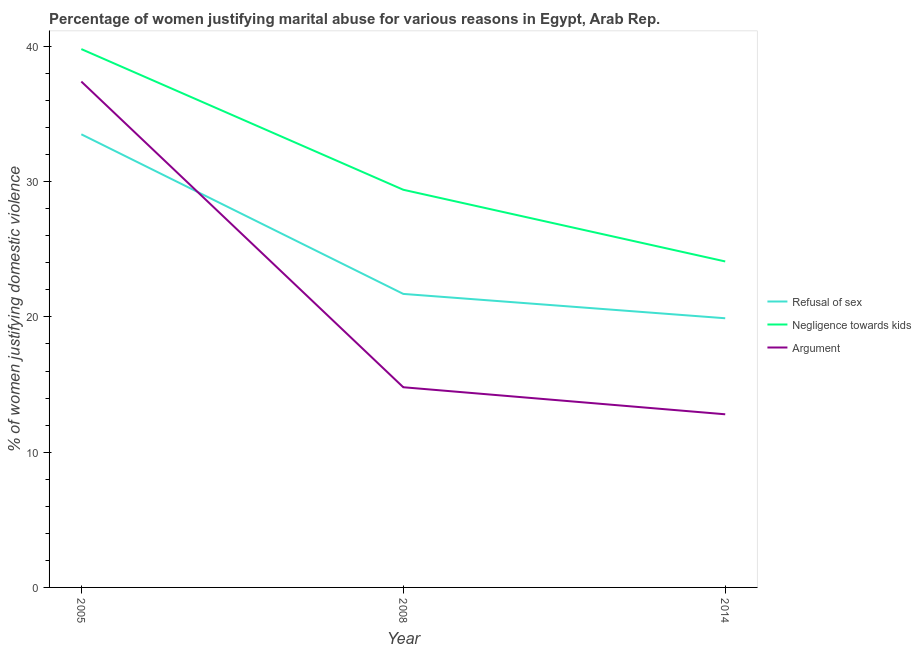Does the line corresponding to percentage of women justifying domestic violence due to refusal of sex intersect with the line corresponding to percentage of women justifying domestic violence due to negligence towards kids?
Keep it short and to the point. No. Across all years, what is the maximum percentage of women justifying domestic violence due to negligence towards kids?
Keep it short and to the point. 39.8. Across all years, what is the minimum percentage of women justifying domestic violence due to negligence towards kids?
Your response must be concise. 24.1. What is the total percentage of women justifying domestic violence due to negligence towards kids in the graph?
Your answer should be very brief. 93.3. What is the difference between the percentage of women justifying domestic violence due to negligence towards kids in 2008 and that in 2014?
Ensure brevity in your answer.  5.3. What is the difference between the percentage of women justifying domestic violence due to refusal of sex in 2008 and the percentage of women justifying domestic violence due to arguments in 2005?
Offer a terse response. -15.7. What is the average percentage of women justifying domestic violence due to refusal of sex per year?
Give a very brief answer. 25.03. In the year 2008, what is the difference between the percentage of women justifying domestic violence due to negligence towards kids and percentage of women justifying domestic violence due to arguments?
Provide a succinct answer. 14.6. In how many years, is the percentage of women justifying domestic violence due to refusal of sex greater than 30 %?
Make the answer very short. 1. What is the ratio of the percentage of women justifying domestic violence due to negligence towards kids in 2005 to that in 2008?
Your answer should be very brief. 1.35. What is the difference between the highest and the second highest percentage of women justifying domestic violence due to negligence towards kids?
Offer a very short reply. 10.4. What is the difference between the highest and the lowest percentage of women justifying domestic violence due to refusal of sex?
Your answer should be very brief. 13.6. Is the sum of the percentage of women justifying domestic violence due to arguments in 2005 and 2014 greater than the maximum percentage of women justifying domestic violence due to negligence towards kids across all years?
Your answer should be very brief. Yes. Is it the case that in every year, the sum of the percentage of women justifying domestic violence due to refusal of sex and percentage of women justifying domestic violence due to negligence towards kids is greater than the percentage of women justifying domestic violence due to arguments?
Offer a terse response. Yes. Does the percentage of women justifying domestic violence due to negligence towards kids monotonically increase over the years?
Give a very brief answer. No. Is the percentage of women justifying domestic violence due to negligence towards kids strictly greater than the percentage of women justifying domestic violence due to refusal of sex over the years?
Provide a succinct answer. Yes. Is the percentage of women justifying domestic violence due to arguments strictly less than the percentage of women justifying domestic violence due to negligence towards kids over the years?
Your answer should be very brief. Yes. How many lines are there?
Ensure brevity in your answer.  3. Does the graph contain grids?
Provide a succinct answer. No. Where does the legend appear in the graph?
Offer a very short reply. Center right. How are the legend labels stacked?
Give a very brief answer. Vertical. What is the title of the graph?
Offer a very short reply. Percentage of women justifying marital abuse for various reasons in Egypt, Arab Rep. What is the label or title of the Y-axis?
Ensure brevity in your answer.  % of women justifying domestic violence. What is the % of women justifying domestic violence in Refusal of sex in 2005?
Provide a short and direct response. 33.5. What is the % of women justifying domestic violence of Negligence towards kids in 2005?
Provide a short and direct response. 39.8. What is the % of women justifying domestic violence of Argument in 2005?
Your answer should be very brief. 37.4. What is the % of women justifying domestic violence in Refusal of sex in 2008?
Your answer should be compact. 21.7. What is the % of women justifying domestic violence in Negligence towards kids in 2008?
Your answer should be compact. 29.4. What is the % of women justifying domestic violence of Refusal of sex in 2014?
Make the answer very short. 19.9. What is the % of women justifying domestic violence in Negligence towards kids in 2014?
Offer a terse response. 24.1. Across all years, what is the maximum % of women justifying domestic violence in Refusal of sex?
Offer a terse response. 33.5. Across all years, what is the maximum % of women justifying domestic violence in Negligence towards kids?
Keep it short and to the point. 39.8. Across all years, what is the maximum % of women justifying domestic violence of Argument?
Your answer should be compact. 37.4. Across all years, what is the minimum % of women justifying domestic violence in Negligence towards kids?
Offer a very short reply. 24.1. Across all years, what is the minimum % of women justifying domestic violence of Argument?
Make the answer very short. 12.8. What is the total % of women justifying domestic violence of Refusal of sex in the graph?
Your answer should be compact. 75.1. What is the total % of women justifying domestic violence of Negligence towards kids in the graph?
Give a very brief answer. 93.3. What is the difference between the % of women justifying domestic violence in Negligence towards kids in 2005 and that in 2008?
Your answer should be very brief. 10.4. What is the difference between the % of women justifying domestic violence in Argument in 2005 and that in 2008?
Offer a very short reply. 22.6. What is the difference between the % of women justifying domestic violence of Negligence towards kids in 2005 and that in 2014?
Offer a very short reply. 15.7. What is the difference between the % of women justifying domestic violence of Argument in 2005 and that in 2014?
Provide a short and direct response. 24.6. What is the difference between the % of women justifying domestic violence in Negligence towards kids in 2008 and that in 2014?
Give a very brief answer. 5.3. What is the difference between the % of women justifying domestic violence in Argument in 2008 and that in 2014?
Offer a terse response. 2. What is the difference between the % of women justifying domestic violence in Refusal of sex in 2005 and the % of women justifying domestic violence in Negligence towards kids in 2008?
Provide a short and direct response. 4.1. What is the difference between the % of women justifying domestic violence of Negligence towards kids in 2005 and the % of women justifying domestic violence of Argument in 2008?
Your response must be concise. 25. What is the difference between the % of women justifying domestic violence in Refusal of sex in 2005 and the % of women justifying domestic violence in Negligence towards kids in 2014?
Provide a short and direct response. 9.4. What is the difference between the % of women justifying domestic violence of Refusal of sex in 2005 and the % of women justifying domestic violence of Argument in 2014?
Your answer should be very brief. 20.7. What is the difference between the % of women justifying domestic violence of Refusal of sex in 2008 and the % of women justifying domestic violence of Argument in 2014?
Offer a very short reply. 8.9. What is the difference between the % of women justifying domestic violence of Negligence towards kids in 2008 and the % of women justifying domestic violence of Argument in 2014?
Ensure brevity in your answer.  16.6. What is the average % of women justifying domestic violence in Refusal of sex per year?
Provide a succinct answer. 25.03. What is the average % of women justifying domestic violence in Negligence towards kids per year?
Keep it short and to the point. 31.1. What is the average % of women justifying domestic violence of Argument per year?
Keep it short and to the point. 21.67. In the year 2005, what is the difference between the % of women justifying domestic violence of Refusal of sex and % of women justifying domestic violence of Negligence towards kids?
Ensure brevity in your answer.  -6.3. In the year 2005, what is the difference between the % of women justifying domestic violence in Refusal of sex and % of women justifying domestic violence in Argument?
Make the answer very short. -3.9. In the year 2008, what is the difference between the % of women justifying domestic violence in Refusal of sex and % of women justifying domestic violence in Negligence towards kids?
Give a very brief answer. -7.7. In the year 2014, what is the difference between the % of women justifying domestic violence in Refusal of sex and % of women justifying domestic violence in Negligence towards kids?
Ensure brevity in your answer.  -4.2. In the year 2014, what is the difference between the % of women justifying domestic violence in Refusal of sex and % of women justifying domestic violence in Argument?
Ensure brevity in your answer.  7.1. What is the ratio of the % of women justifying domestic violence of Refusal of sex in 2005 to that in 2008?
Keep it short and to the point. 1.54. What is the ratio of the % of women justifying domestic violence of Negligence towards kids in 2005 to that in 2008?
Provide a short and direct response. 1.35. What is the ratio of the % of women justifying domestic violence of Argument in 2005 to that in 2008?
Offer a very short reply. 2.53. What is the ratio of the % of women justifying domestic violence of Refusal of sex in 2005 to that in 2014?
Ensure brevity in your answer.  1.68. What is the ratio of the % of women justifying domestic violence of Negligence towards kids in 2005 to that in 2014?
Provide a succinct answer. 1.65. What is the ratio of the % of women justifying domestic violence in Argument in 2005 to that in 2014?
Your answer should be compact. 2.92. What is the ratio of the % of women justifying domestic violence of Refusal of sex in 2008 to that in 2014?
Ensure brevity in your answer.  1.09. What is the ratio of the % of women justifying domestic violence of Negligence towards kids in 2008 to that in 2014?
Your answer should be compact. 1.22. What is the ratio of the % of women justifying domestic violence in Argument in 2008 to that in 2014?
Offer a very short reply. 1.16. What is the difference between the highest and the second highest % of women justifying domestic violence of Refusal of sex?
Your response must be concise. 11.8. What is the difference between the highest and the second highest % of women justifying domestic violence of Negligence towards kids?
Offer a terse response. 10.4. What is the difference between the highest and the second highest % of women justifying domestic violence of Argument?
Make the answer very short. 22.6. What is the difference between the highest and the lowest % of women justifying domestic violence in Refusal of sex?
Keep it short and to the point. 13.6. What is the difference between the highest and the lowest % of women justifying domestic violence of Negligence towards kids?
Give a very brief answer. 15.7. What is the difference between the highest and the lowest % of women justifying domestic violence in Argument?
Your response must be concise. 24.6. 